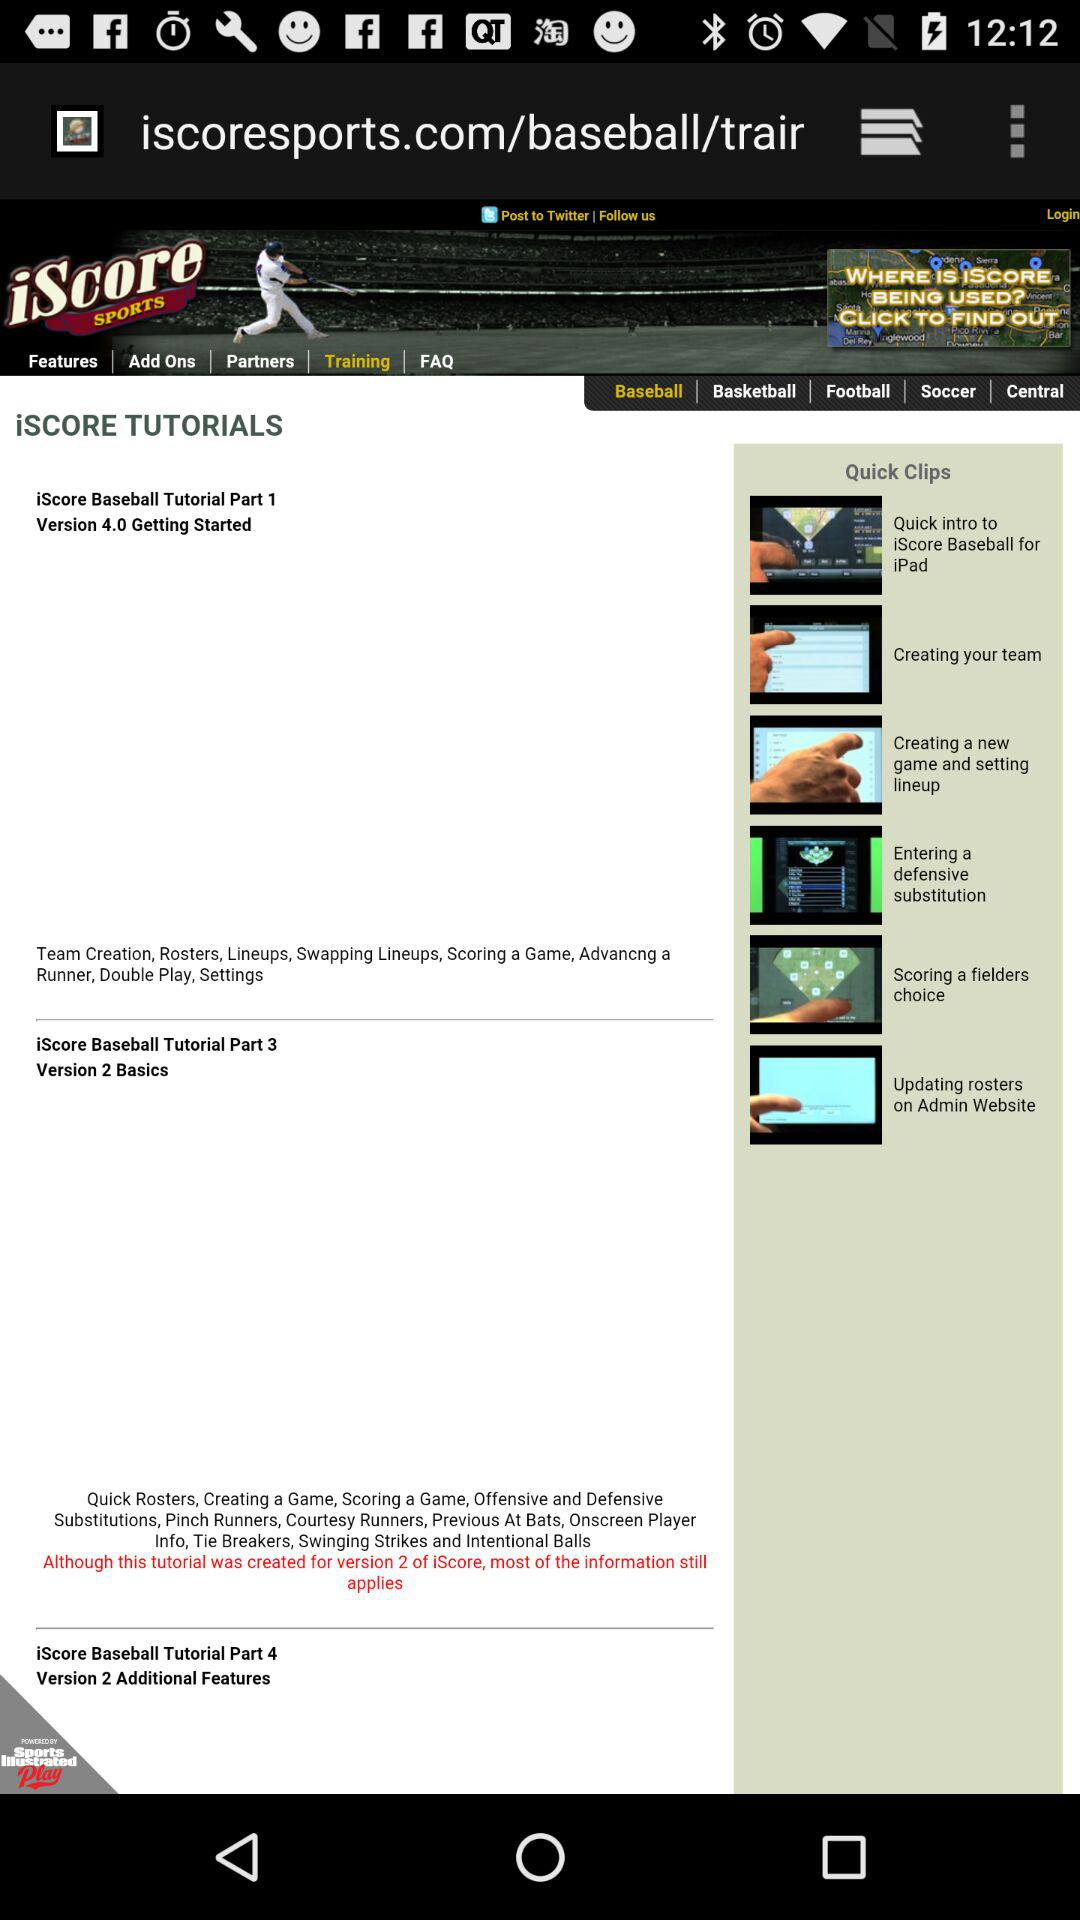What's the version number of "iScore Baseball Tutorial Part 3"? The version number of "iScore Baseball Tutorial Part 3" is 2. 